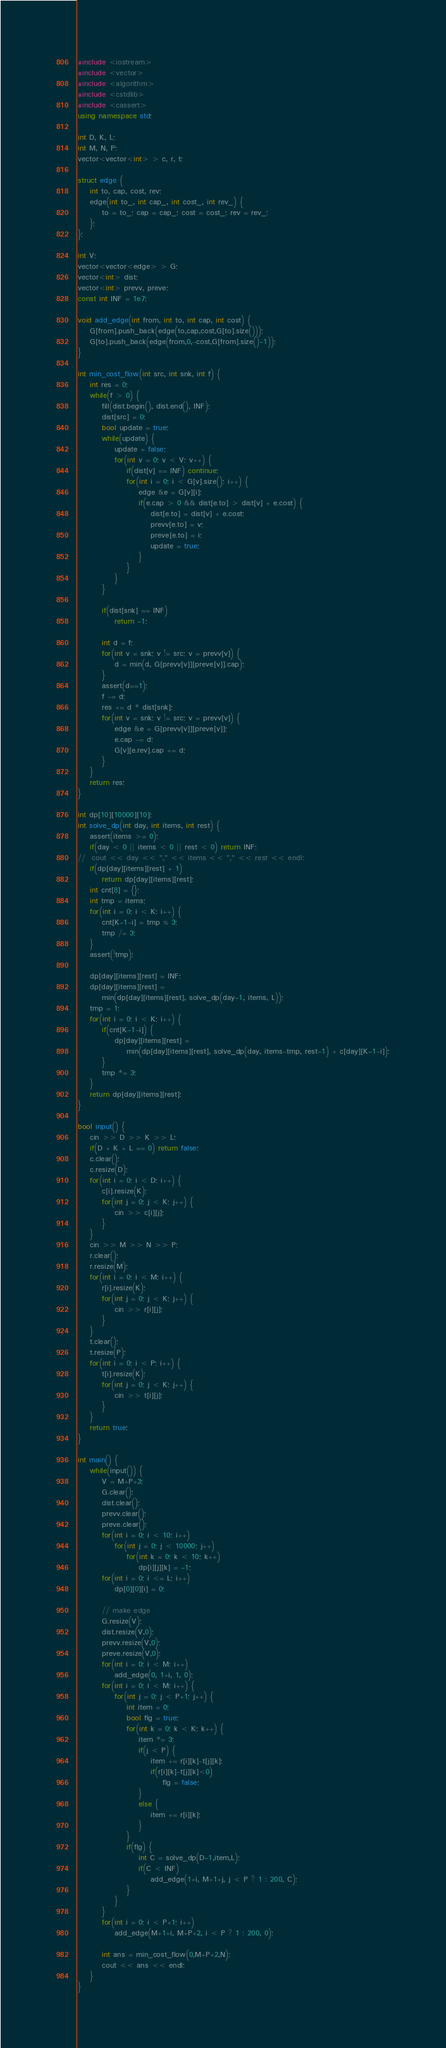<code> <loc_0><loc_0><loc_500><loc_500><_C++_>#include <iostream>
#include <vector>
#include <algorithm>
#include <cstdlib>
#include <cassert>
using namespace std;

int D, K, L;
int M, N, P;
vector<vector<int> > c, r, t;

struct edge {
	int to, cap, cost, rev;
	edge(int to_, int cap_, int cost_, int rev_) {
		to = to_; cap = cap_; cost = cost_; rev = rev_;
	};
};

int V;
vector<vector<edge> > G;
vector<int> dist;
vector<int> prevv, preve;
const int INF = 1e7;

void add_edge(int from, int to, int cap, int cost) {
	G[from].push_back(edge(to,cap,cost,G[to].size()));
	G[to].push_back(edge(from,0,-cost,G[from].size()-1));
}

int min_cost_flow(int src, int snk, int f) {
	int res = 0;
	while(f > 0) {
		fill(dist.begin(), dist.end(), INF);
		dist[src] = 0;
		bool update = true;
		while(update) {
			update = false;
			for(int v = 0; v < V; v++) {
				if(dist[v] == INF) continue;
				for(int i = 0; i < G[v].size(); i++) {
					edge &e = G[v][i];
					if(e.cap > 0 && dist[e.to] > dist[v] + e.cost) {
						dist[e.to] = dist[v] + e.cost;
						prevv[e.to] = v;
						preve[e.to] = i;
						update = true;
					}
				}
			}
		}

		if(dist[snk] == INF)
			return -1;

		int d = f;
		for(int v = snk; v != src; v = prevv[v]) {
			d = min(d, G[prevv[v]][preve[v]].cap);
		}
		assert(d==1);
		f -= d;
		res += d * dist[snk];
		for(int v = snk; v != src; v = prevv[v]) {
			edge &e = G[prevv[v]][preve[v]];
			e.cap -= d;
			G[v][e.rev].cap += d;
		}
	}
	return res;
}

int dp[10][10000][10];
int solve_dp(int day, int items, int rest) {
	assert(items >= 0);
	if(day < 0 || items < 0 || rest < 0) return INF;
//	cout << day << "," << items << "," << rest << endl;
	if(dp[day][items][rest] + 1)
		return dp[day][items][rest];
	int cnt[8] = {};
	int tmp = items;
	for(int i = 0; i < K; i++) {
		cnt[K-1-i] = tmp % 3;
		tmp /= 3;
	}
	assert(!tmp);

	dp[day][items][rest] = INF;
	dp[day][items][rest] =
		min(dp[day][items][rest], solve_dp(day-1, items, L));
	tmp = 1;
	for(int i = 0; i < K; i++) {
		if(cnt[K-1-i]) {
			dp[day][items][rest] =
				min(dp[day][items][rest], solve_dp(day, items-tmp, rest-1) + c[day][K-1-i]);
		}
		tmp *= 3;
	}
	return dp[day][items][rest];
}

bool input() {
	cin >> D >> K >> L;
	if(D + K + L == 0) return false;
	c.clear();
	c.resize(D);
	for(int i = 0; i < D; i++) {
		c[i].resize(K);
		for(int j = 0; j < K; j++) {
			cin >> c[i][j];
		}
	}
	cin >> M >> N >> P;
	r.clear();
	r.resize(M);
	for(int i = 0; i < M; i++) {
		r[i].resize(K);
		for(int j = 0; j < K; j++) {
			cin >> r[i][j];
		}
	}
	t.clear();
	t.resize(P);
	for(int i = 0; i < P; i++) {
		t[i].resize(K);
		for(int j = 0; j < K; j++) {
			cin >> t[i][j];
		}
	}
	return true;
}

int main() {
	while(input()) {
		V = M+P+3;
		G.clear();
		dist.clear();
		prevv.clear();
		preve.clear();
		for(int i = 0; i < 10; i++)
			for(int j = 0; j < 10000; j++)
				for(int k = 0; k < 10; k++)
					dp[i][j][k] = -1;
		for(int i = 0; i <= L; i++)
			dp[0][0][i] = 0;

		// make edge
		G.resize(V);
		dist.resize(V,0);
		prevv.resize(V,0);
		preve.resize(V,0);
		for(int i = 0; i < M; i++)
			add_edge(0, 1+i, 1, 0);
		for(int i = 0; i < M; i++) {
			for(int j = 0; j < P+1; j++) {
				int item = 0;
				bool flg = true;
				for(int k = 0; k < K; k++) {
					item *= 3;
					if(j < P) {
						item += r[i][k]-t[j][k];
						if(r[i][k]-t[j][k]<0)
							flg = false;
					}
					else {
						item += r[i][k];
					}
				}
				if(flg) {
					int C = solve_dp(D-1,item,L);
					if(C < INF)
						add_edge(1+i, M+1+j, j < P ? 1 : 200, C);
				}
			}
		}
		for(int i = 0; i < P+1; i++)
			add_edge(M+1+i, M+P+2, i < P ? 1 : 200, 0);

		int ans = min_cost_flow(0,M+P+2,N);
		cout << ans << endl;
	}
}</code> 